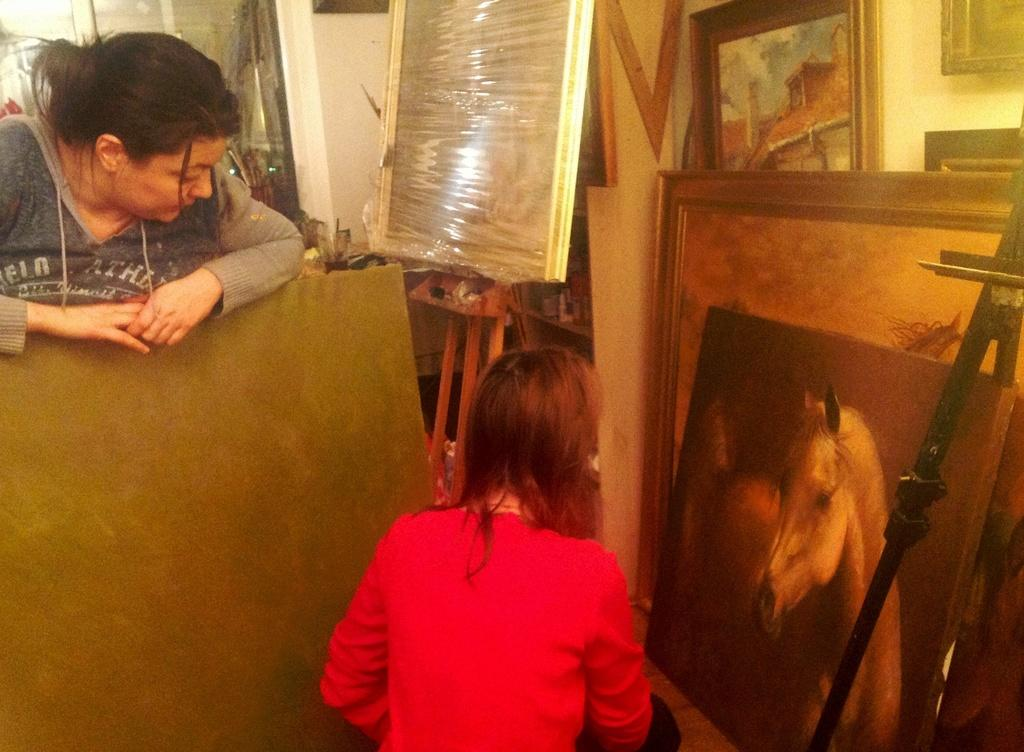How many people are present in the image? There are two people in the image. What is the background element in the image? There is a wall in the image. What type of decorative items can be seen in the image? There are frames in the image. What other objects are visible in the image? There are objects in the image. What is the board on a stand used for in the image? The board on a stand is likely used for displaying or presenting information. What type of books are being exchanged between the two people in the image? There are no books present in the image, and no exchange is taking place between the two people. What color is the wall in the image? The provided facts do not mention the color of the wall, so it cannot be determined from the image. 